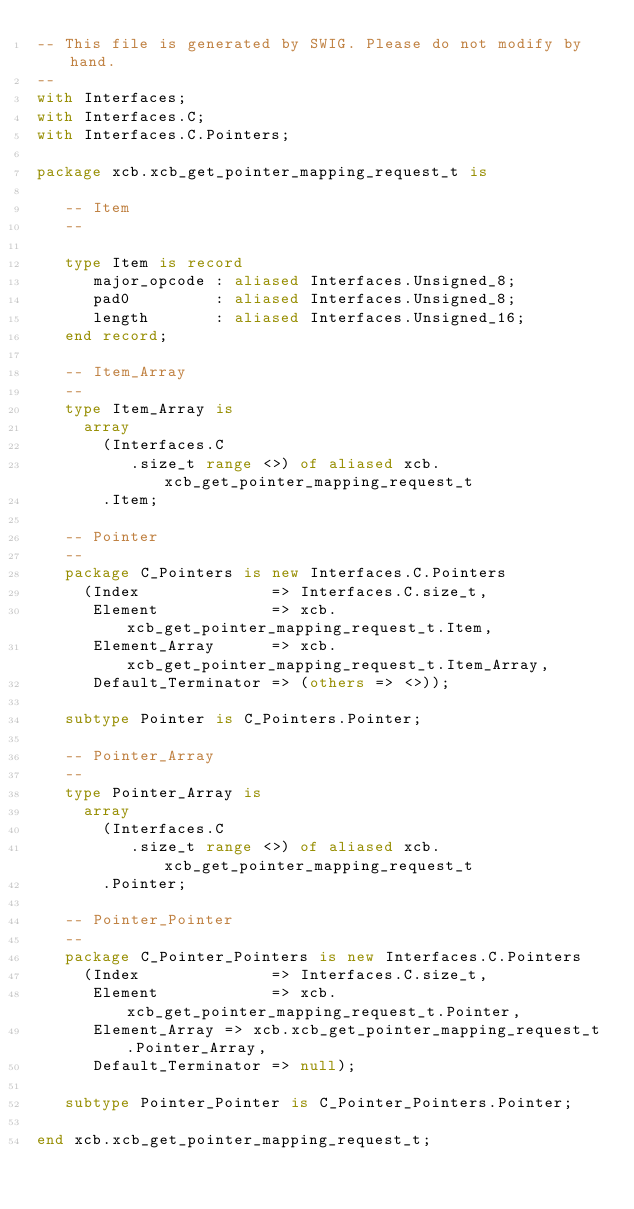Convert code to text. <code><loc_0><loc_0><loc_500><loc_500><_Ada_>-- This file is generated by SWIG. Please do not modify by hand.
--
with Interfaces;
with Interfaces.C;
with Interfaces.C.Pointers;

package xcb.xcb_get_pointer_mapping_request_t is

   -- Item
   --

   type Item is record
      major_opcode : aliased Interfaces.Unsigned_8;
      pad0         : aliased Interfaces.Unsigned_8;
      length       : aliased Interfaces.Unsigned_16;
   end record;

   -- Item_Array
   --
   type Item_Array is
     array
       (Interfaces.C
          .size_t range <>) of aliased xcb.xcb_get_pointer_mapping_request_t
       .Item;

   -- Pointer
   --
   package C_Pointers is new Interfaces.C.Pointers
     (Index              => Interfaces.C.size_t,
      Element            => xcb.xcb_get_pointer_mapping_request_t.Item,
      Element_Array      => xcb.xcb_get_pointer_mapping_request_t.Item_Array,
      Default_Terminator => (others => <>));

   subtype Pointer is C_Pointers.Pointer;

   -- Pointer_Array
   --
   type Pointer_Array is
     array
       (Interfaces.C
          .size_t range <>) of aliased xcb.xcb_get_pointer_mapping_request_t
       .Pointer;

   -- Pointer_Pointer
   --
   package C_Pointer_Pointers is new Interfaces.C.Pointers
     (Index              => Interfaces.C.size_t,
      Element            => xcb.xcb_get_pointer_mapping_request_t.Pointer,
      Element_Array => xcb.xcb_get_pointer_mapping_request_t.Pointer_Array,
      Default_Terminator => null);

   subtype Pointer_Pointer is C_Pointer_Pointers.Pointer;

end xcb.xcb_get_pointer_mapping_request_t;
</code> 